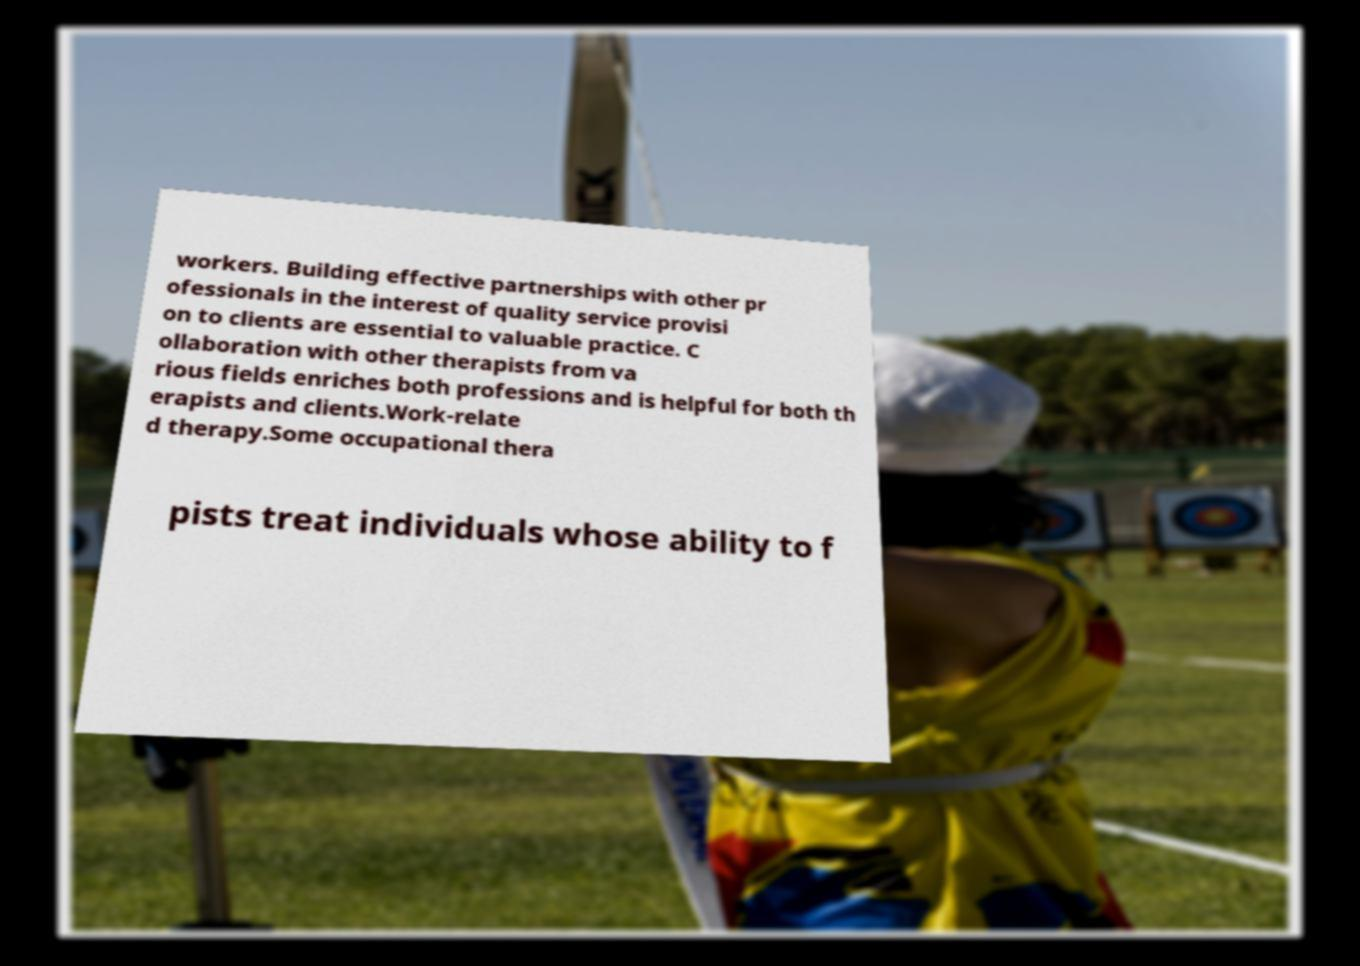What messages or text are displayed in this image? I need them in a readable, typed format. workers. Building effective partnerships with other pr ofessionals in the interest of quality service provisi on to clients are essential to valuable practice. C ollaboration with other therapists from va rious fields enriches both professions and is helpful for both th erapists and clients.Work-relate d therapy.Some occupational thera pists treat individuals whose ability to f 